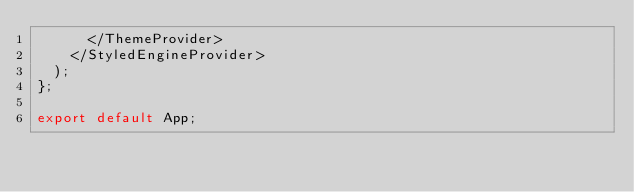<code> <loc_0><loc_0><loc_500><loc_500><_JavaScript_>      </ThemeProvider>
    </StyledEngineProvider>
  );
};

export default App;
</code> 